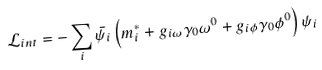<formula> <loc_0><loc_0><loc_500><loc_500>\mathcal { L } _ { i n t } = - \sum _ { i } \bar { \psi _ { i } } \left ( m ^ { * } _ { i } + g _ { i \omega } \gamma _ { 0 } \omega ^ { 0 } + g _ { i \phi } \gamma _ { 0 } \phi ^ { 0 } \right ) \psi _ { i } \</formula> 